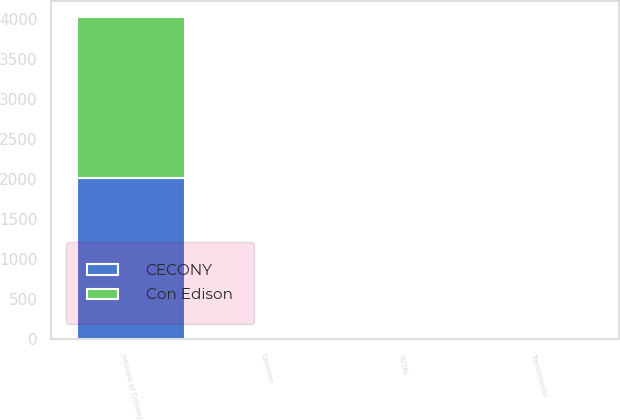Convert chart. <chart><loc_0><loc_0><loc_500><loc_500><stacked_bar_chart><ecel><fcel>(Millions of Dollars)<fcel>Transmission<fcel>Common<fcel>TOTAL<nl><fcel>CECONY<fcel>2010<fcel>2<fcel>11<fcel>13<nl><fcel>Con Edison<fcel>2010<fcel>2<fcel>11<fcel>13<nl></chart> 